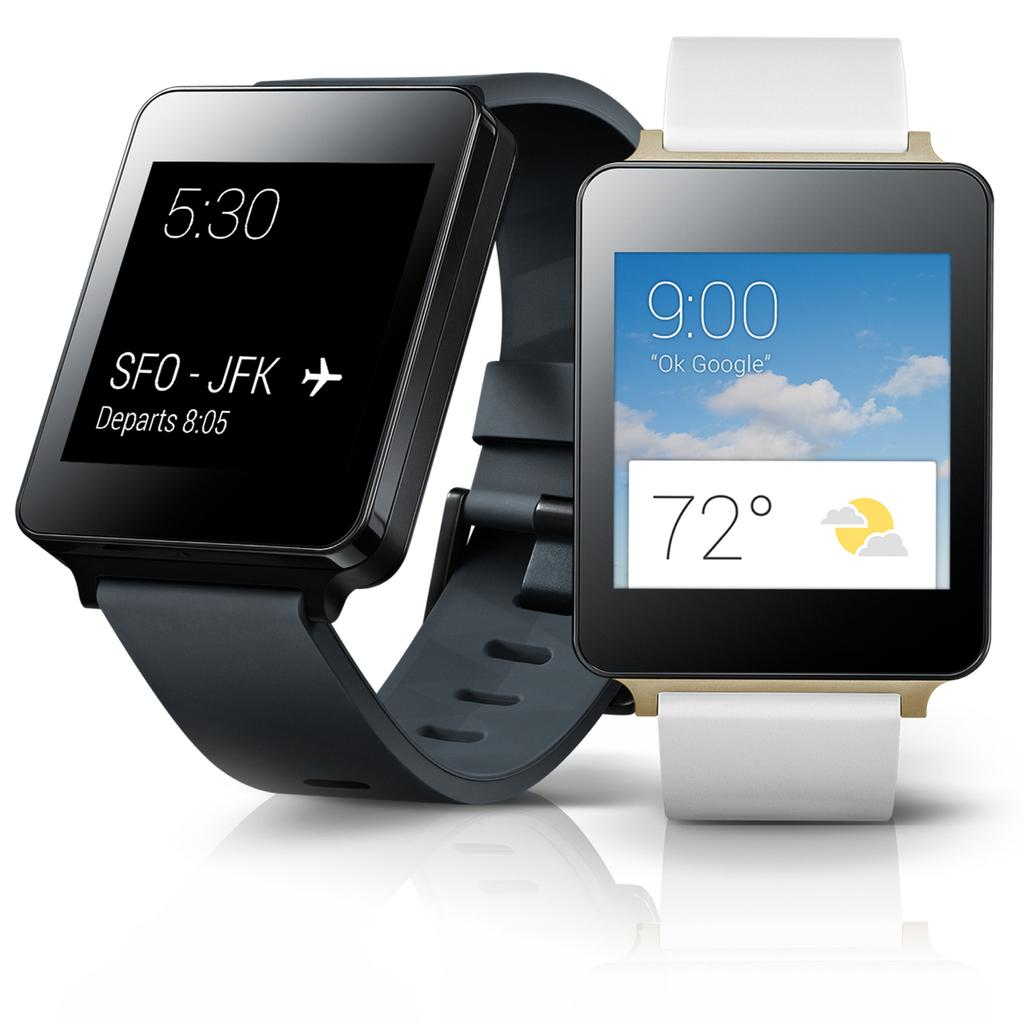<image>
Render a clear and concise summary of the photo. A smart watch shows flight details going from San Francisco to New York City. 